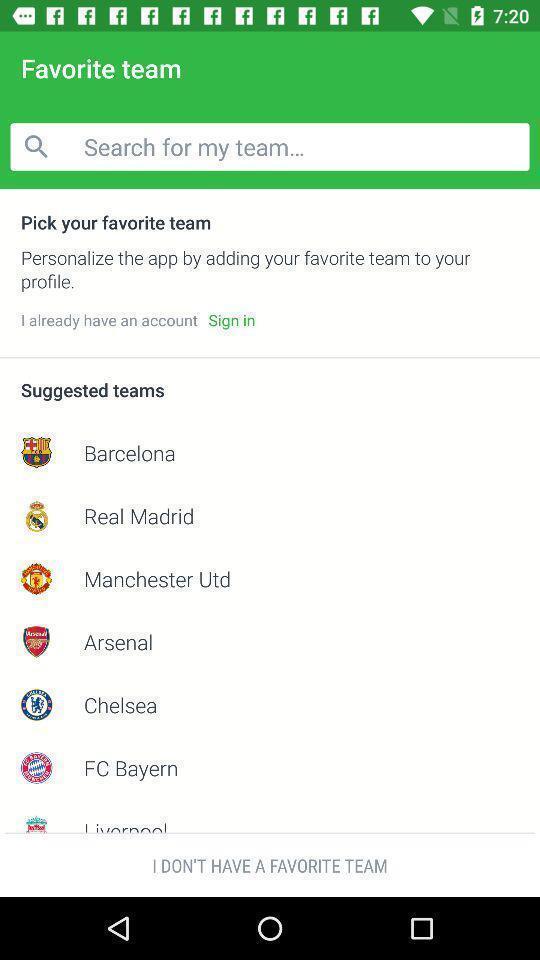Explain what's happening in this screen capture. Search page and suggested teams displayed. 